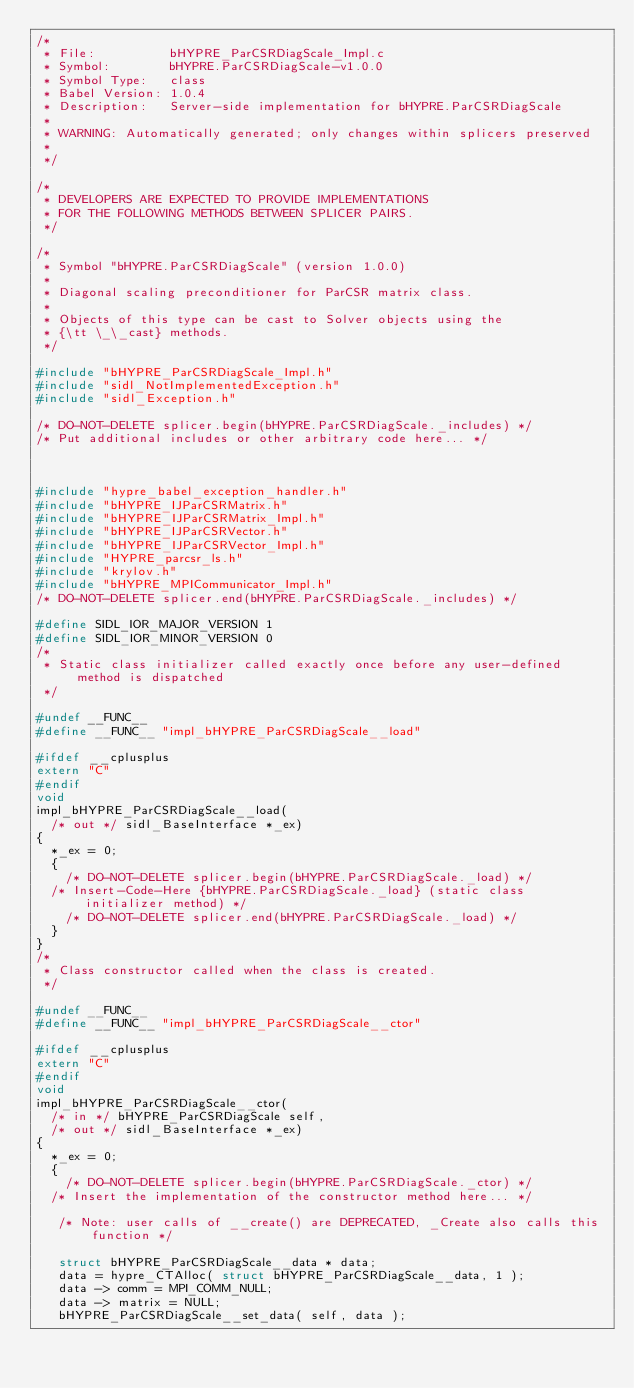<code> <loc_0><loc_0><loc_500><loc_500><_C_>/*
 * File:          bHYPRE_ParCSRDiagScale_Impl.c
 * Symbol:        bHYPRE.ParCSRDiagScale-v1.0.0
 * Symbol Type:   class
 * Babel Version: 1.0.4
 * Description:   Server-side implementation for bHYPRE.ParCSRDiagScale
 * 
 * WARNING: Automatically generated; only changes within splicers preserved
 * 
 */

/*
 * DEVELOPERS ARE EXPECTED TO PROVIDE IMPLEMENTATIONS
 * FOR THE FOLLOWING METHODS BETWEEN SPLICER PAIRS.
 */

/*
 * Symbol "bHYPRE.ParCSRDiagScale" (version 1.0.0)
 * 
 * Diagonal scaling preconditioner for ParCSR matrix class.
 * 
 * Objects of this type can be cast to Solver objects using the
 * {\tt \_\_cast} methods.
 */

#include "bHYPRE_ParCSRDiagScale_Impl.h"
#include "sidl_NotImplementedException.h"
#include "sidl_Exception.h"

/* DO-NOT-DELETE splicer.begin(bHYPRE.ParCSRDiagScale._includes) */
/* Put additional includes or other arbitrary code here... */



#include "hypre_babel_exception_handler.h"
#include "bHYPRE_IJParCSRMatrix.h"
#include "bHYPRE_IJParCSRMatrix_Impl.h"
#include "bHYPRE_IJParCSRVector.h"
#include "bHYPRE_IJParCSRVector_Impl.h"
#include "HYPRE_parcsr_ls.h"
#include "krylov.h"
#include "bHYPRE_MPICommunicator_Impl.h"
/* DO-NOT-DELETE splicer.end(bHYPRE.ParCSRDiagScale._includes) */

#define SIDL_IOR_MAJOR_VERSION 1
#define SIDL_IOR_MINOR_VERSION 0
/*
 * Static class initializer called exactly once before any user-defined method is dispatched
 */

#undef __FUNC__
#define __FUNC__ "impl_bHYPRE_ParCSRDiagScale__load"

#ifdef __cplusplus
extern "C"
#endif
void
impl_bHYPRE_ParCSRDiagScale__load(
  /* out */ sidl_BaseInterface *_ex)
{
  *_ex = 0;
  {
    /* DO-NOT-DELETE splicer.begin(bHYPRE.ParCSRDiagScale._load) */
  /* Insert-Code-Here {bHYPRE.ParCSRDiagScale._load} (static class initializer method) */
    /* DO-NOT-DELETE splicer.end(bHYPRE.ParCSRDiagScale._load) */
  }
}
/*
 * Class constructor called when the class is created.
 */

#undef __FUNC__
#define __FUNC__ "impl_bHYPRE_ParCSRDiagScale__ctor"

#ifdef __cplusplus
extern "C"
#endif
void
impl_bHYPRE_ParCSRDiagScale__ctor(
  /* in */ bHYPRE_ParCSRDiagScale self,
  /* out */ sidl_BaseInterface *_ex)
{
  *_ex = 0;
  {
    /* DO-NOT-DELETE splicer.begin(bHYPRE.ParCSRDiagScale._ctor) */
  /* Insert the implementation of the constructor method here... */

   /* Note: user calls of __create() are DEPRECATED, _Create also calls this function */

   struct bHYPRE_ParCSRDiagScale__data * data;
   data = hypre_CTAlloc( struct bHYPRE_ParCSRDiagScale__data, 1 );
   data -> comm = MPI_COMM_NULL;
   data -> matrix = NULL;
   bHYPRE_ParCSRDiagScale__set_data( self, data );</code> 